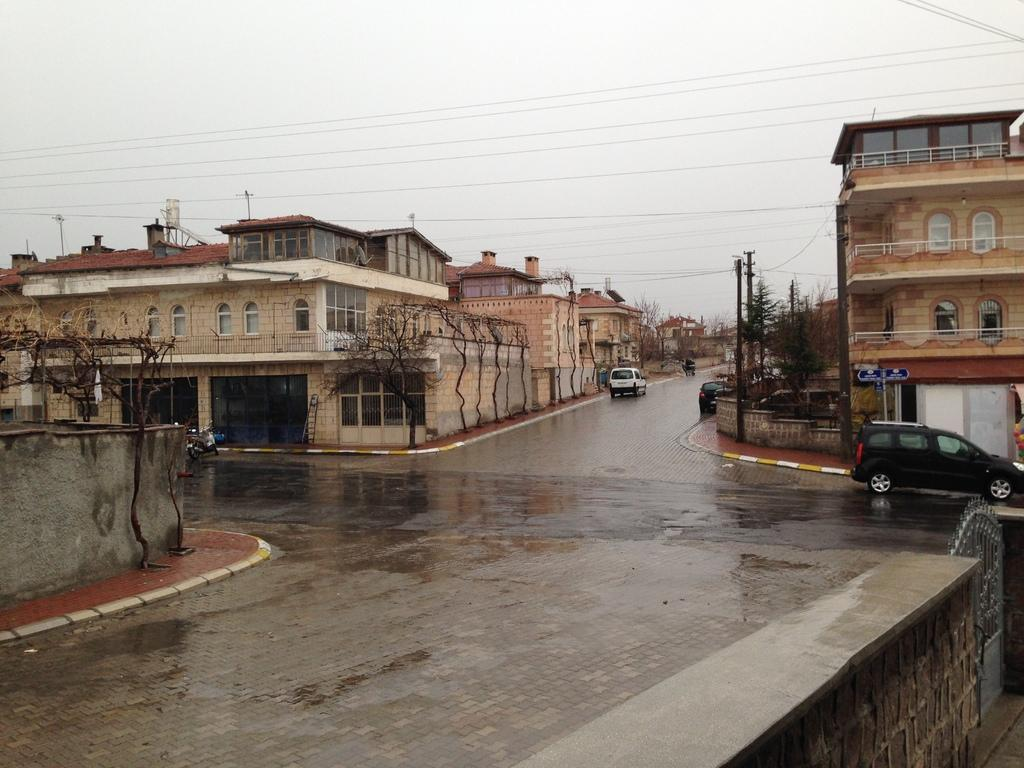What types of vehicles can be seen on the roads in the image? There are motor vehicles on the roads in the image. What structures are visible in the image? There are buildings in the image. What type of natural elements can be seen in the image? There are trees in the image. What infrastructure elements are present in the image? Electric poles and railings are present in the image. What is visible in the sky in the image? The sky is visible in the image. Can you tell me how many chickens are standing on the electric poles in the image? There are no chickens present on the electric poles in the image. What type of insurance policy is being advertised on the buildings in the image? There is no insurance policy being advertised on the buildings in the image. 